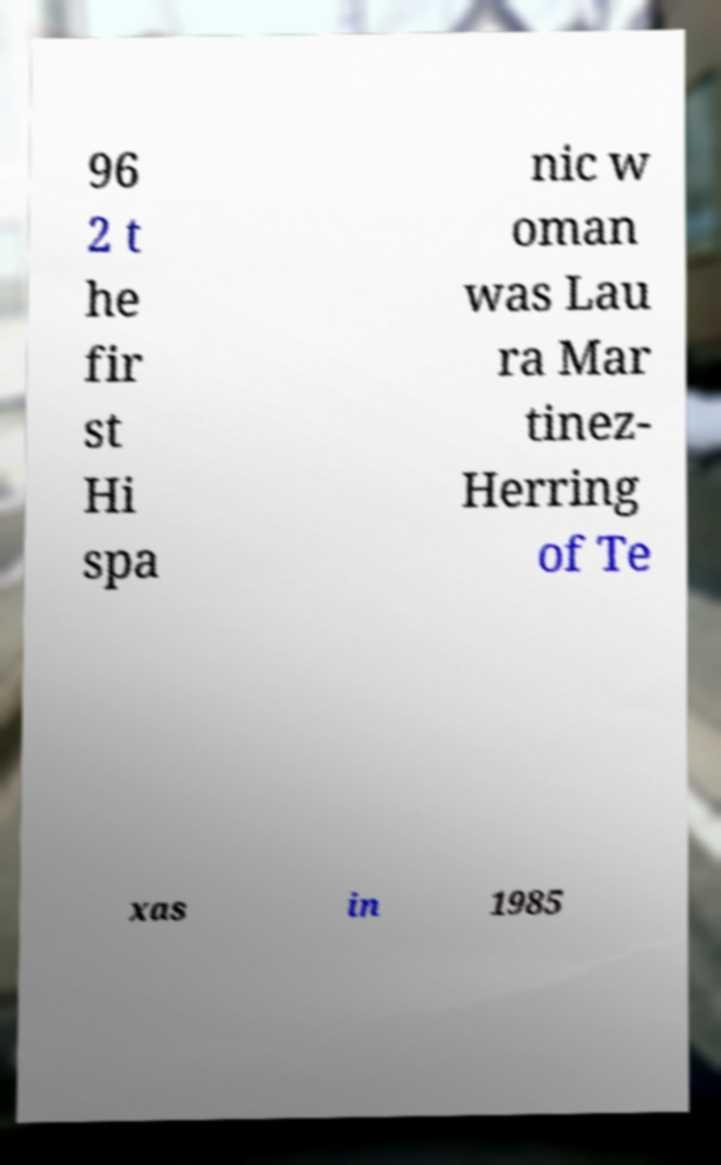Please identify and transcribe the text found in this image. 96 2 t he fir st Hi spa nic w oman was Lau ra Mar tinez- Herring of Te xas in 1985 